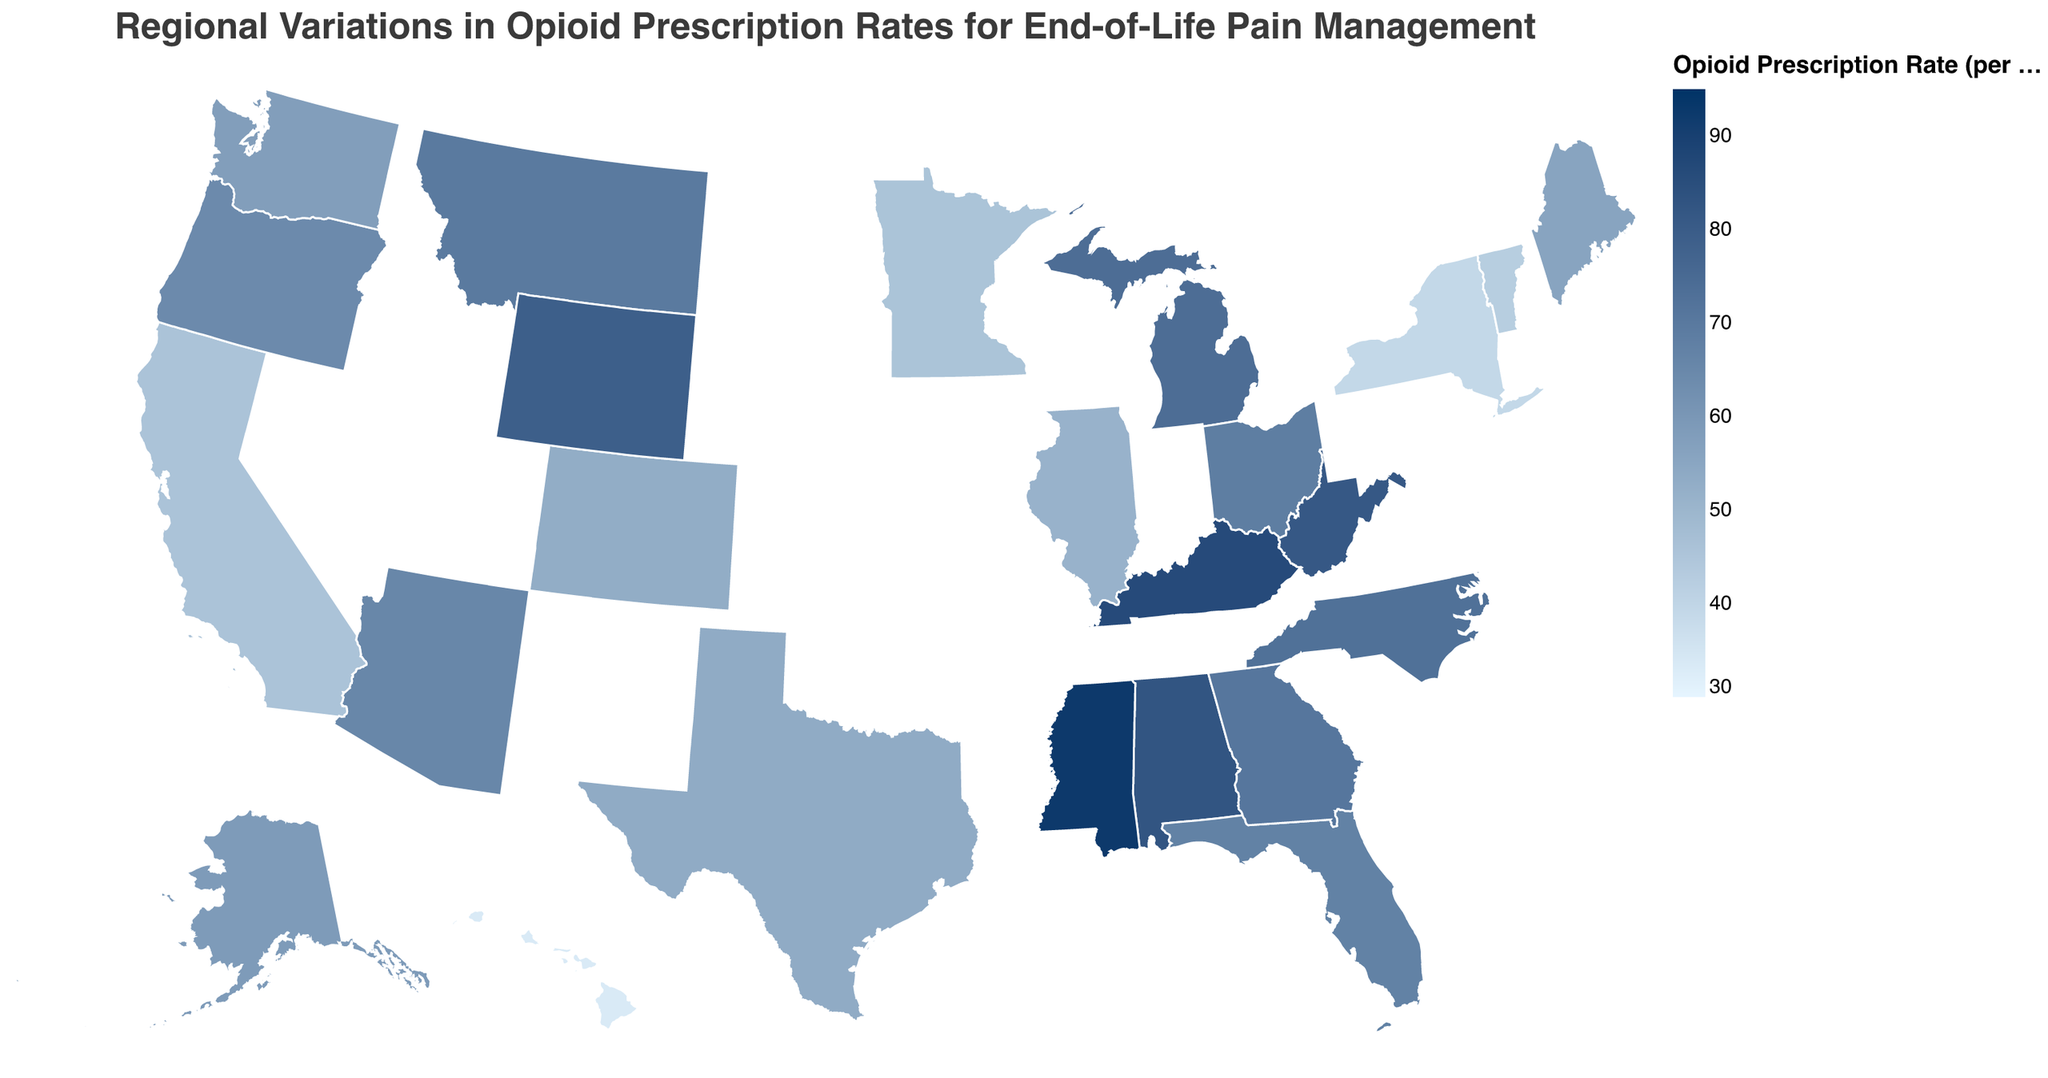How is the title of the figure phrased? The title is located at the top center of the figure and reads "Regional Variations in Opioid Prescription Rates for End-of-Life Pain Management".
Answer: Regional Variations in Opioid Prescription Rates for End-of-Life Pain Management Which state has the highest opioid prescription rate? In the figure, states are shaded in varying colors to indicate opioid prescription rates. The darkest shade corresponds to the highest rate. Mississippi is in the darkest shade with a rate of 92.6 per 100 patients.
Answer: Mississippi Compare the opioid prescription rates between California and New York. Which state has a lower rate? California and New York are both in the legend and can be identified on the map by their respective colors. California's rate is 45.8, while New York's is 39.1, so New York has a lower rate.
Answer: New York Which states have opioid prescription rates above 80 per 100 patients? States with opioid prescription rates above 80 are a darker color. By looking at the figure, the states with rates above 80 are Alabama, Kentucky, Mississippi, West Virginia, and Wyoming.
Answer: Alabama, Kentucky, Mississippi, West Virginia, Wyoming What is the range of the opioid prescription rates? The legend provides the range of the opioid prescription rates, which are shown with colors scaling from lightest to darkest. The range of the rates is from 30 to 95 per 100 patients.
Answer: 30 to 95 Identify the region with the lowest opioid prescription rates and provide the name of a state from that region. The lightest shade indicates the lowest rates. One of the lightest shades is seen in Hawaii, which has the lowest rate of 33.4 per 100 patients.
Answer: Hawaii What is the average opioid prescription rate of the states bordering the west coast (California, Oregon, and Washington)? California's rate is 45.8, Oregon's rate is 64.2, and Washington's rate is 57.6. Adding these gives 45.8 + 64.2 + 57.6 = 167.6. Dividing by 3 gives the average rate of 167.6 / 3 ≈ 55.9 per 100 patients.
Answer: 55.9 per 100 patients Which states have an opioid prescription rate closest to the median rate of the data? To find the median, the rates must be ordered: 33.4, 39.1, 42.3, 45.6, 45.8, 51.2, 52.9, 53.4, 55.7, 57.6, 58.7, 64.2, 65.3, 67.1, 68.5, 69.8, 70.9, 72.8, 74.0, 78.9, 81.3, 82.5, 86.3, 92.6. The median is between the 12th (57.6) and 13th (58.7) data points. Therefore, the median rate is approximately 58.2. Washington (57.6) and Alaska (58.7) have rates closest to this median.
Answer: Washington, Alaska Which states are represented with the second darkest color, indicating opioid prescription rates of approximately 70-80 per 100 patients? The second darkest color in the legend represents rates from 70 to 80 per 100 patients. From the figure, these states are Georgia, Michigan, Montana, North Carolina, and Wyoming.
Answer: Georgia, Michigan, Montana, North Carolina, Wyoming 